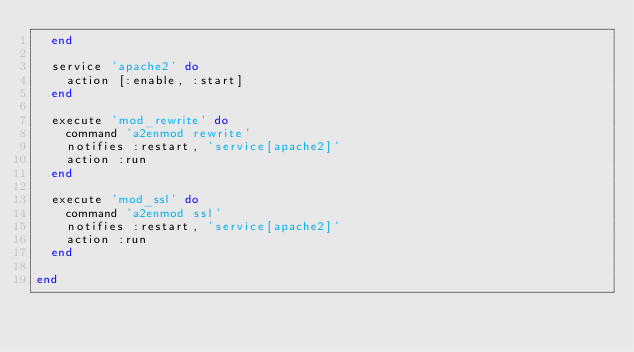<code> <loc_0><loc_0><loc_500><loc_500><_Ruby_>  end

  service 'apache2' do
    action [:enable, :start]
  end

  execute 'mod_rewrite' do
    command 'a2enmod rewrite'
    notifies :restart, 'service[apache2]'
    action :run
  end

  execute 'mod_ssl' do
    command 'a2enmod ssl'
    notifies :restart, 'service[apache2]'
    action :run
  end

end

</code> 